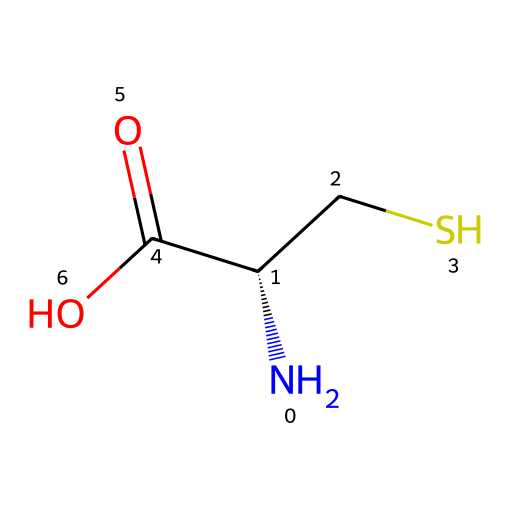What is the name of the amino acid represented by this SMILES? The SMILES notation shows the structure of cysteine, which is identified by the presence of the thiol (-SH) group indicated by the "CS" portion.
Answer: cysteine How many carbon atoms are in this molecule? Analyzing the SMILES, there are three carbon atoms: one in the amino group, one in the carboxylic acid group, and one in the side chain (-CS).
Answer: three What functional group is present in the side chain of cysteine? The side chain "CS" in the SMILES indicates the presence of a thiol functional group (-SH), which contains sulfur.
Answer: thiol How many total hydrogen atoms are in cysteine? From the structure, there are seven hydrogen atoms accounted for: two from the amino group (NH2), one from the carboxylic acid (COOH), and three from the side chain (-CS) plus one in the CH group.
Answer: seven What is the charge of the carboxylic acid group at physiological pH? The carboxylic acid group (C(=O)O) tends to lose a hydrogen ion (H+) at physiological pH, making it negatively charged.
Answer: negative Is cysteine considered an essential or non-essential amino acid? Since cysteine can be synthesized by the body from methionine, it is classified as a non-essential amino acid.
Answer: non-essential 